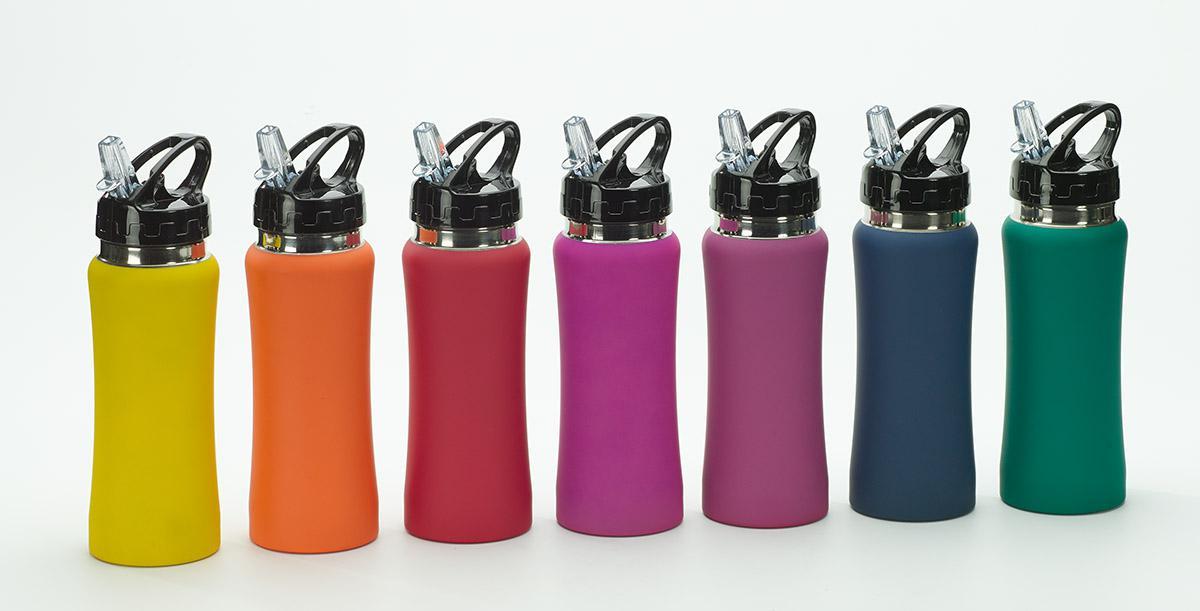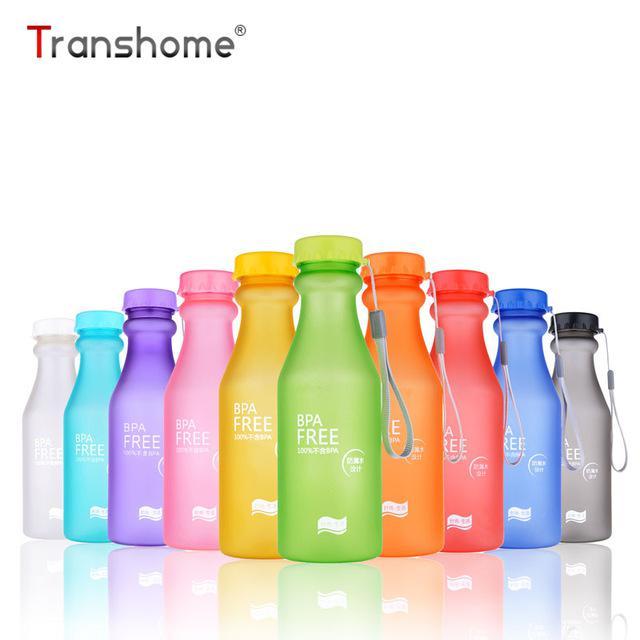The first image is the image on the left, the second image is the image on the right. Assess this claim about the two images: "Each image contains multiple water bottles in different solid colors, and one image shows bottles arranged in a V-formation.". Correct or not? Answer yes or no. Yes. The first image is the image on the left, the second image is the image on the right. For the images shown, is this caption "There are two green bottles." true? Answer yes or no. Yes. 